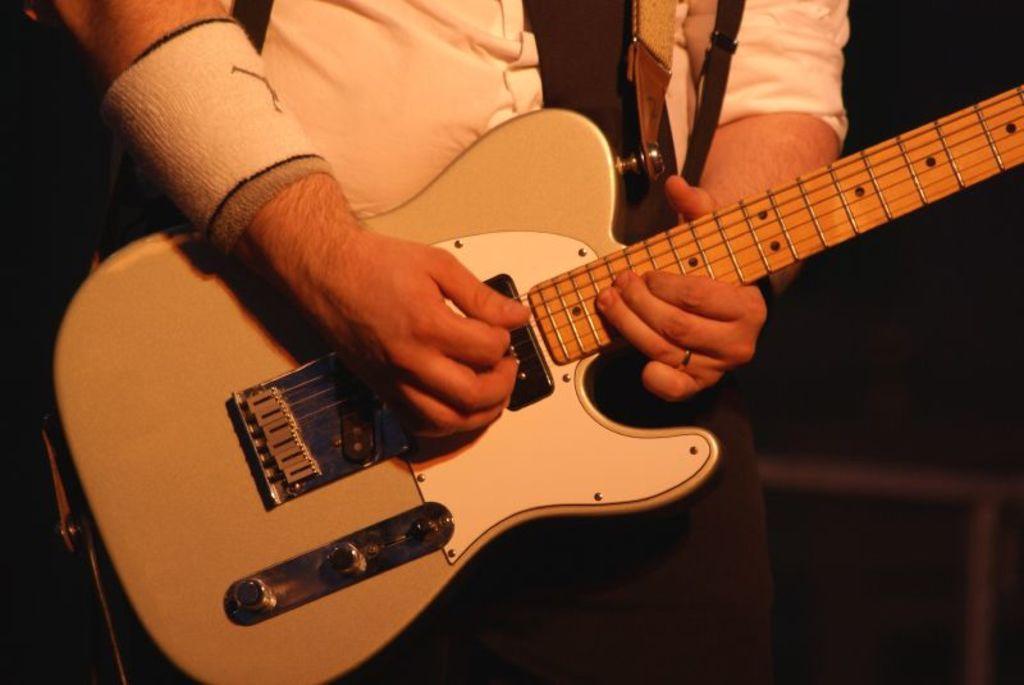Can you describe this image briefly? In this image there is a man he wear white shirt ,he holds a guitar ,he is playing guitar. 